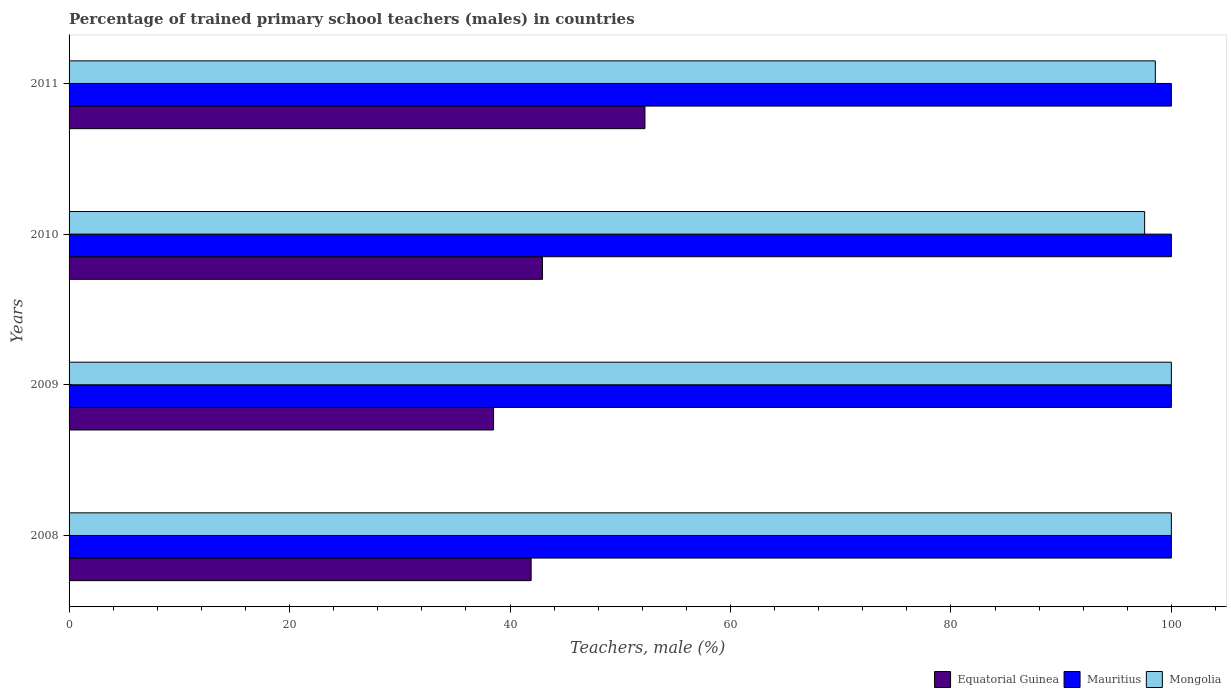Are the number of bars per tick equal to the number of legend labels?
Offer a very short reply. Yes. How many bars are there on the 1st tick from the bottom?
Keep it short and to the point. 3. What is the percentage of trained primary school teachers (males) in Mongolia in 2010?
Keep it short and to the point. 97.57. Across all years, what is the minimum percentage of trained primary school teachers (males) in Equatorial Guinea?
Make the answer very short. 38.51. In which year was the percentage of trained primary school teachers (males) in Equatorial Guinea minimum?
Provide a short and direct response. 2009. What is the total percentage of trained primary school teachers (males) in Mongolia in the graph?
Offer a very short reply. 396.12. What is the difference between the percentage of trained primary school teachers (males) in Equatorial Guinea in 2008 and that in 2010?
Ensure brevity in your answer.  -1.03. What is the difference between the percentage of trained primary school teachers (males) in Mongolia in 2010 and the percentage of trained primary school teachers (males) in Equatorial Guinea in 2008?
Offer a very short reply. 55.66. What is the average percentage of trained primary school teachers (males) in Equatorial Guinea per year?
Provide a short and direct response. 43.9. In the year 2008, what is the difference between the percentage of trained primary school teachers (males) in Equatorial Guinea and percentage of trained primary school teachers (males) in Mongolia?
Keep it short and to the point. -58.08. In how many years, is the percentage of trained primary school teachers (males) in Mongolia greater than 24 %?
Offer a terse response. 4. What is the ratio of the percentage of trained primary school teachers (males) in Mauritius in 2009 to that in 2011?
Provide a succinct answer. 1. Is the percentage of trained primary school teachers (males) in Mauritius in 2008 less than that in 2010?
Make the answer very short. No. Is the difference between the percentage of trained primary school teachers (males) in Equatorial Guinea in 2008 and 2011 greater than the difference between the percentage of trained primary school teachers (males) in Mongolia in 2008 and 2011?
Your answer should be very brief. No. What is the difference between the highest and the second highest percentage of trained primary school teachers (males) in Mongolia?
Make the answer very short. 0. What is the difference between the highest and the lowest percentage of trained primary school teachers (males) in Mauritius?
Give a very brief answer. 0. Is the sum of the percentage of trained primary school teachers (males) in Equatorial Guinea in 2009 and 2010 greater than the maximum percentage of trained primary school teachers (males) in Mongolia across all years?
Give a very brief answer. No. What does the 1st bar from the top in 2009 represents?
Ensure brevity in your answer.  Mongolia. What does the 3rd bar from the bottom in 2009 represents?
Offer a very short reply. Mongolia. Is it the case that in every year, the sum of the percentage of trained primary school teachers (males) in Mongolia and percentage of trained primary school teachers (males) in Equatorial Guinea is greater than the percentage of trained primary school teachers (males) in Mauritius?
Your answer should be compact. Yes. How many bars are there?
Make the answer very short. 12. Where does the legend appear in the graph?
Ensure brevity in your answer.  Bottom right. What is the title of the graph?
Your response must be concise. Percentage of trained primary school teachers (males) in countries. What is the label or title of the X-axis?
Your answer should be compact. Teachers, male (%). What is the Teachers, male (%) of Equatorial Guinea in 2008?
Ensure brevity in your answer.  41.92. What is the Teachers, male (%) in Mongolia in 2008?
Give a very brief answer. 100. What is the Teachers, male (%) in Equatorial Guinea in 2009?
Provide a succinct answer. 38.51. What is the Teachers, male (%) in Mongolia in 2009?
Offer a terse response. 100. What is the Teachers, male (%) of Equatorial Guinea in 2010?
Ensure brevity in your answer.  42.95. What is the Teachers, male (%) in Mongolia in 2010?
Keep it short and to the point. 97.57. What is the Teachers, male (%) of Equatorial Guinea in 2011?
Offer a terse response. 52.24. What is the Teachers, male (%) of Mongolia in 2011?
Offer a terse response. 98.55. Across all years, what is the maximum Teachers, male (%) of Equatorial Guinea?
Keep it short and to the point. 52.24. Across all years, what is the maximum Teachers, male (%) in Mauritius?
Offer a terse response. 100. Across all years, what is the maximum Teachers, male (%) of Mongolia?
Give a very brief answer. 100. Across all years, what is the minimum Teachers, male (%) in Equatorial Guinea?
Give a very brief answer. 38.51. Across all years, what is the minimum Teachers, male (%) of Mongolia?
Make the answer very short. 97.57. What is the total Teachers, male (%) in Equatorial Guinea in the graph?
Provide a short and direct response. 175.62. What is the total Teachers, male (%) of Mongolia in the graph?
Keep it short and to the point. 396.12. What is the difference between the Teachers, male (%) in Equatorial Guinea in 2008 and that in 2009?
Your response must be concise. 3.41. What is the difference between the Teachers, male (%) of Mauritius in 2008 and that in 2009?
Make the answer very short. 0. What is the difference between the Teachers, male (%) of Equatorial Guinea in 2008 and that in 2010?
Offer a very short reply. -1.03. What is the difference between the Teachers, male (%) in Mauritius in 2008 and that in 2010?
Offer a very short reply. 0. What is the difference between the Teachers, male (%) of Mongolia in 2008 and that in 2010?
Your answer should be compact. 2.43. What is the difference between the Teachers, male (%) of Equatorial Guinea in 2008 and that in 2011?
Your response must be concise. -10.32. What is the difference between the Teachers, male (%) of Mauritius in 2008 and that in 2011?
Keep it short and to the point. 0. What is the difference between the Teachers, male (%) of Mongolia in 2008 and that in 2011?
Keep it short and to the point. 1.45. What is the difference between the Teachers, male (%) in Equatorial Guinea in 2009 and that in 2010?
Keep it short and to the point. -4.44. What is the difference between the Teachers, male (%) of Mongolia in 2009 and that in 2010?
Make the answer very short. 2.43. What is the difference between the Teachers, male (%) in Equatorial Guinea in 2009 and that in 2011?
Offer a terse response. -13.73. What is the difference between the Teachers, male (%) in Mongolia in 2009 and that in 2011?
Provide a short and direct response. 1.45. What is the difference between the Teachers, male (%) of Equatorial Guinea in 2010 and that in 2011?
Your response must be concise. -9.3. What is the difference between the Teachers, male (%) of Mongolia in 2010 and that in 2011?
Your answer should be compact. -0.97. What is the difference between the Teachers, male (%) of Equatorial Guinea in 2008 and the Teachers, male (%) of Mauritius in 2009?
Ensure brevity in your answer.  -58.08. What is the difference between the Teachers, male (%) in Equatorial Guinea in 2008 and the Teachers, male (%) in Mongolia in 2009?
Give a very brief answer. -58.08. What is the difference between the Teachers, male (%) of Mauritius in 2008 and the Teachers, male (%) of Mongolia in 2009?
Your response must be concise. 0. What is the difference between the Teachers, male (%) in Equatorial Guinea in 2008 and the Teachers, male (%) in Mauritius in 2010?
Your answer should be very brief. -58.08. What is the difference between the Teachers, male (%) in Equatorial Guinea in 2008 and the Teachers, male (%) in Mongolia in 2010?
Provide a succinct answer. -55.66. What is the difference between the Teachers, male (%) of Mauritius in 2008 and the Teachers, male (%) of Mongolia in 2010?
Offer a very short reply. 2.43. What is the difference between the Teachers, male (%) in Equatorial Guinea in 2008 and the Teachers, male (%) in Mauritius in 2011?
Your answer should be very brief. -58.08. What is the difference between the Teachers, male (%) of Equatorial Guinea in 2008 and the Teachers, male (%) of Mongolia in 2011?
Your response must be concise. -56.63. What is the difference between the Teachers, male (%) of Mauritius in 2008 and the Teachers, male (%) of Mongolia in 2011?
Make the answer very short. 1.45. What is the difference between the Teachers, male (%) in Equatorial Guinea in 2009 and the Teachers, male (%) in Mauritius in 2010?
Your response must be concise. -61.49. What is the difference between the Teachers, male (%) in Equatorial Guinea in 2009 and the Teachers, male (%) in Mongolia in 2010?
Provide a short and direct response. -59.07. What is the difference between the Teachers, male (%) of Mauritius in 2009 and the Teachers, male (%) of Mongolia in 2010?
Keep it short and to the point. 2.43. What is the difference between the Teachers, male (%) of Equatorial Guinea in 2009 and the Teachers, male (%) of Mauritius in 2011?
Give a very brief answer. -61.49. What is the difference between the Teachers, male (%) of Equatorial Guinea in 2009 and the Teachers, male (%) of Mongolia in 2011?
Provide a succinct answer. -60.04. What is the difference between the Teachers, male (%) in Mauritius in 2009 and the Teachers, male (%) in Mongolia in 2011?
Make the answer very short. 1.45. What is the difference between the Teachers, male (%) of Equatorial Guinea in 2010 and the Teachers, male (%) of Mauritius in 2011?
Give a very brief answer. -57.05. What is the difference between the Teachers, male (%) of Equatorial Guinea in 2010 and the Teachers, male (%) of Mongolia in 2011?
Keep it short and to the point. -55.6. What is the difference between the Teachers, male (%) in Mauritius in 2010 and the Teachers, male (%) in Mongolia in 2011?
Your answer should be compact. 1.45. What is the average Teachers, male (%) of Equatorial Guinea per year?
Your response must be concise. 43.9. What is the average Teachers, male (%) in Mauritius per year?
Your response must be concise. 100. What is the average Teachers, male (%) of Mongolia per year?
Keep it short and to the point. 99.03. In the year 2008, what is the difference between the Teachers, male (%) in Equatorial Guinea and Teachers, male (%) in Mauritius?
Offer a very short reply. -58.08. In the year 2008, what is the difference between the Teachers, male (%) in Equatorial Guinea and Teachers, male (%) in Mongolia?
Offer a terse response. -58.08. In the year 2009, what is the difference between the Teachers, male (%) of Equatorial Guinea and Teachers, male (%) of Mauritius?
Offer a terse response. -61.49. In the year 2009, what is the difference between the Teachers, male (%) of Equatorial Guinea and Teachers, male (%) of Mongolia?
Your response must be concise. -61.49. In the year 2010, what is the difference between the Teachers, male (%) in Equatorial Guinea and Teachers, male (%) in Mauritius?
Keep it short and to the point. -57.05. In the year 2010, what is the difference between the Teachers, male (%) in Equatorial Guinea and Teachers, male (%) in Mongolia?
Provide a succinct answer. -54.63. In the year 2010, what is the difference between the Teachers, male (%) of Mauritius and Teachers, male (%) of Mongolia?
Provide a succinct answer. 2.43. In the year 2011, what is the difference between the Teachers, male (%) of Equatorial Guinea and Teachers, male (%) of Mauritius?
Give a very brief answer. -47.76. In the year 2011, what is the difference between the Teachers, male (%) of Equatorial Guinea and Teachers, male (%) of Mongolia?
Provide a short and direct response. -46.3. In the year 2011, what is the difference between the Teachers, male (%) in Mauritius and Teachers, male (%) in Mongolia?
Make the answer very short. 1.45. What is the ratio of the Teachers, male (%) of Equatorial Guinea in 2008 to that in 2009?
Provide a short and direct response. 1.09. What is the ratio of the Teachers, male (%) of Mauritius in 2008 to that in 2009?
Provide a succinct answer. 1. What is the ratio of the Teachers, male (%) in Equatorial Guinea in 2008 to that in 2010?
Ensure brevity in your answer.  0.98. What is the ratio of the Teachers, male (%) in Mauritius in 2008 to that in 2010?
Provide a succinct answer. 1. What is the ratio of the Teachers, male (%) in Mongolia in 2008 to that in 2010?
Your response must be concise. 1.02. What is the ratio of the Teachers, male (%) of Equatorial Guinea in 2008 to that in 2011?
Give a very brief answer. 0.8. What is the ratio of the Teachers, male (%) of Mongolia in 2008 to that in 2011?
Offer a terse response. 1.01. What is the ratio of the Teachers, male (%) in Equatorial Guinea in 2009 to that in 2010?
Ensure brevity in your answer.  0.9. What is the ratio of the Teachers, male (%) in Mongolia in 2009 to that in 2010?
Your answer should be very brief. 1.02. What is the ratio of the Teachers, male (%) of Equatorial Guinea in 2009 to that in 2011?
Give a very brief answer. 0.74. What is the ratio of the Teachers, male (%) in Mauritius in 2009 to that in 2011?
Give a very brief answer. 1. What is the ratio of the Teachers, male (%) in Mongolia in 2009 to that in 2011?
Keep it short and to the point. 1.01. What is the ratio of the Teachers, male (%) of Equatorial Guinea in 2010 to that in 2011?
Your response must be concise. 0.82. What is the ratio of the Teachers, male (%) in Mauritius in 2010 to that in 2011?
Provide a short and direct response. 1. What is the difference between the highest and the second highest Teachers, male (%) in Equatorial Guinea?
Make the answer very short. 9.3. What is the difference between the highest and the second highest Teachers, male (%) in Mongolia?
Offer a very short reply. 0. What is the difference between the highest and the lowest Teachers, male (%) in Equatorial Guinea?
Give a very brief answer. 13.73. What is the difference between the highest and the lowest Teachers, male (%) in Mauritius?
Ensure brevity in your answer.  0. What is the difference between the highest and the lowest Teachers, male (%) of Mongolia?
Make the answer very short. 2.43. 